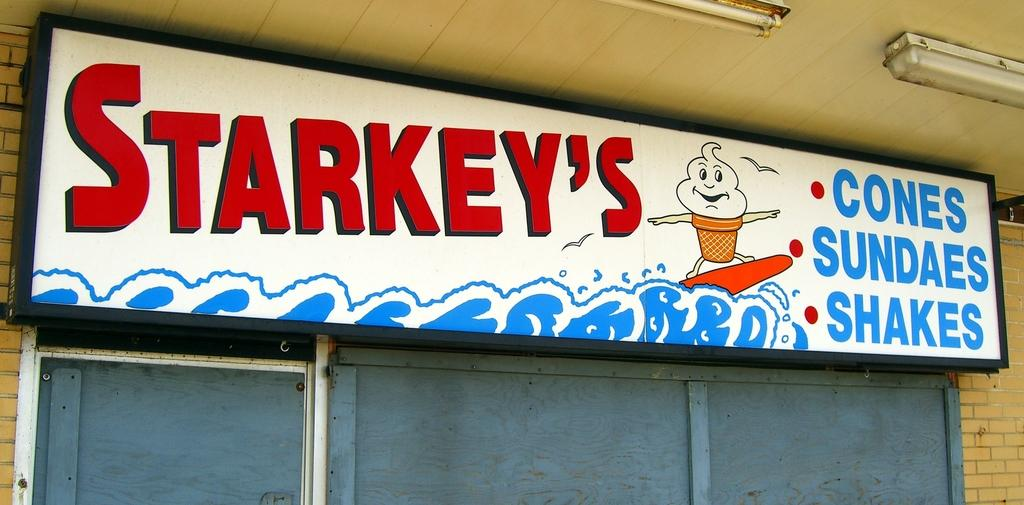<image>
Describe the image concisely. Store front showing an ice cream cone and the name "STARKEY'S". 